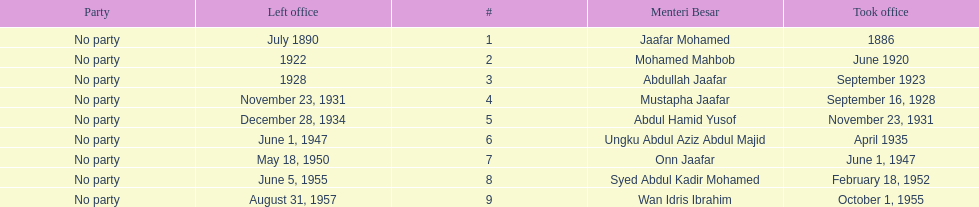What was the date the last person on the list left office? August 31, 1957. 